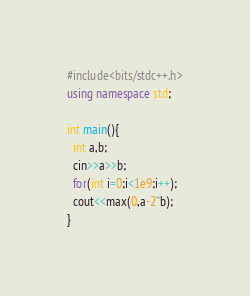<code> <loc_0><loc_0><loc_500><loc_500><_C++_>#include<bits/stdc++.h>
using namespace std;
 
int main(){
  int a,b;
  cin>>a>>b;
  for(int i=0;i<1e9;i++);
  cout<<max(0,a-2*b);
}</code> 